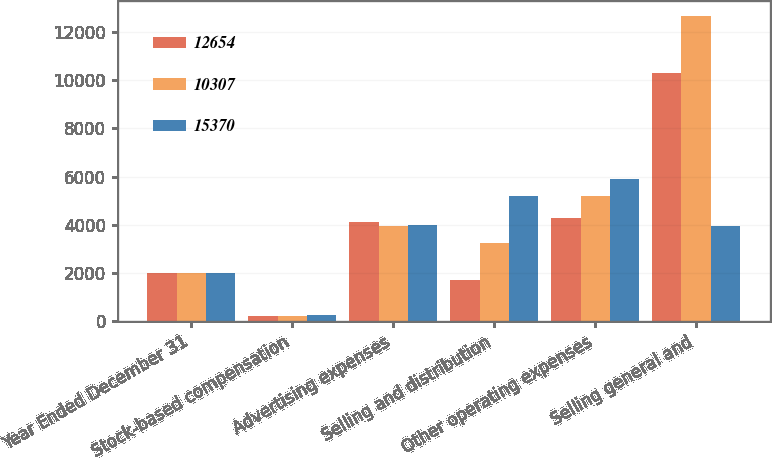<chart> <loc_0><loc_0><loc_500><loc_500><stacked_bar_chart><ecel><fcel>Year Ended December 31<fcel>Stock-based compensation<fcel>Advertising expenses<fcel>Selling and distribution<fcel>Other operating expenses<fcel>Selling general and<nl><fcel>12654<fcel>2018<fcel>225<fcel>4113<fcel>1701<fcel>4268<fcel>10307<nl><fcel>10307<fcel>2017<fcel>219<fcel>3958<fcel>3266<fcel>5211<fcel>12654<nl><fcel>15370<fcel>2016<fcel>258<fcel>4004<fcel>5189<fcel>5919<fcel>3958<nl></chart> 